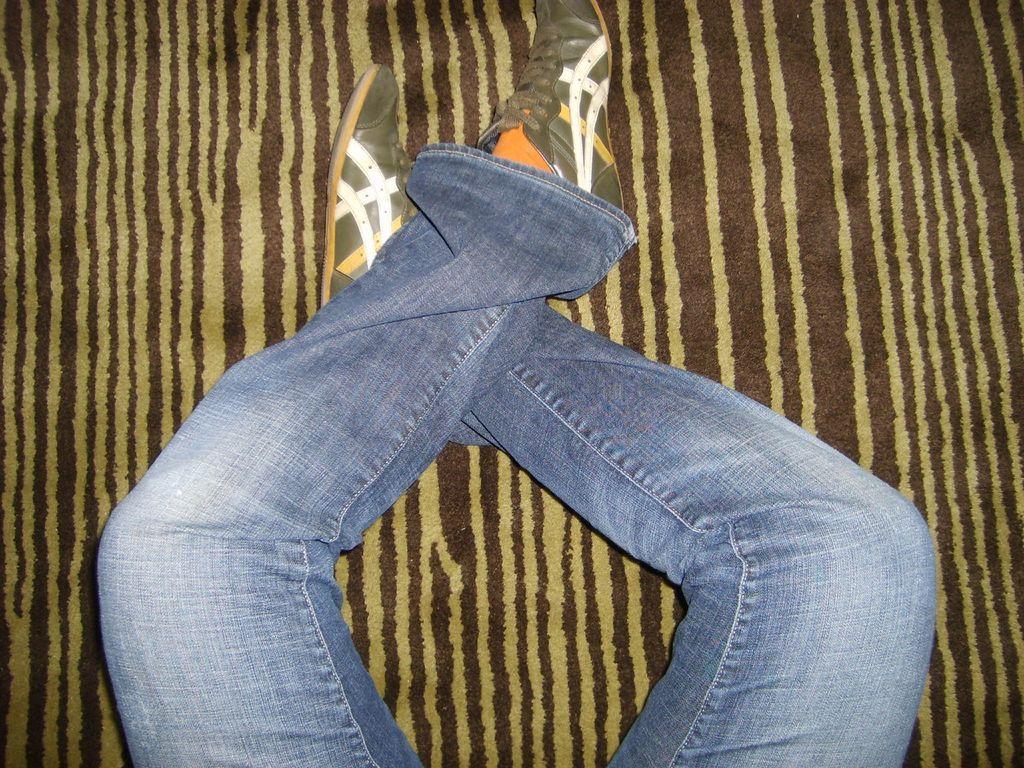Describe this image in one or two sentences. In this picture we can see the legs of a person wearing shoes and denim jeans. In the background we can see a cloth. 